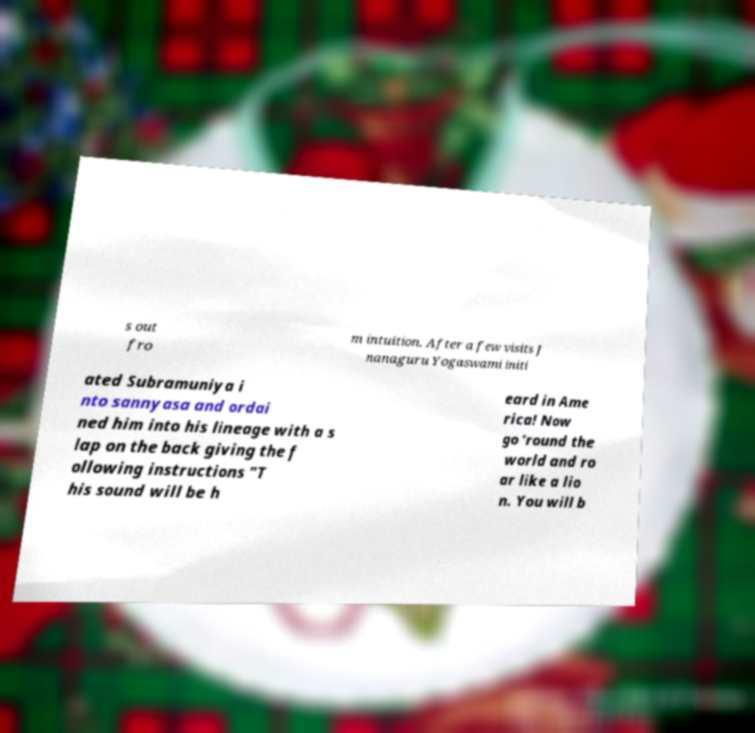Please identify and transcribe the text found in this image. s out fro m intuition. After a few visits J nanaguru Yogaswami initi ated Subramuniya i nto sannyasa and ordai ned him into his lineage with a s lap on the back giving the f ollowing instructions "T his sound will be h eard in Ame rica! Now go ‘round the world and ro ar like a lio n. You will b 